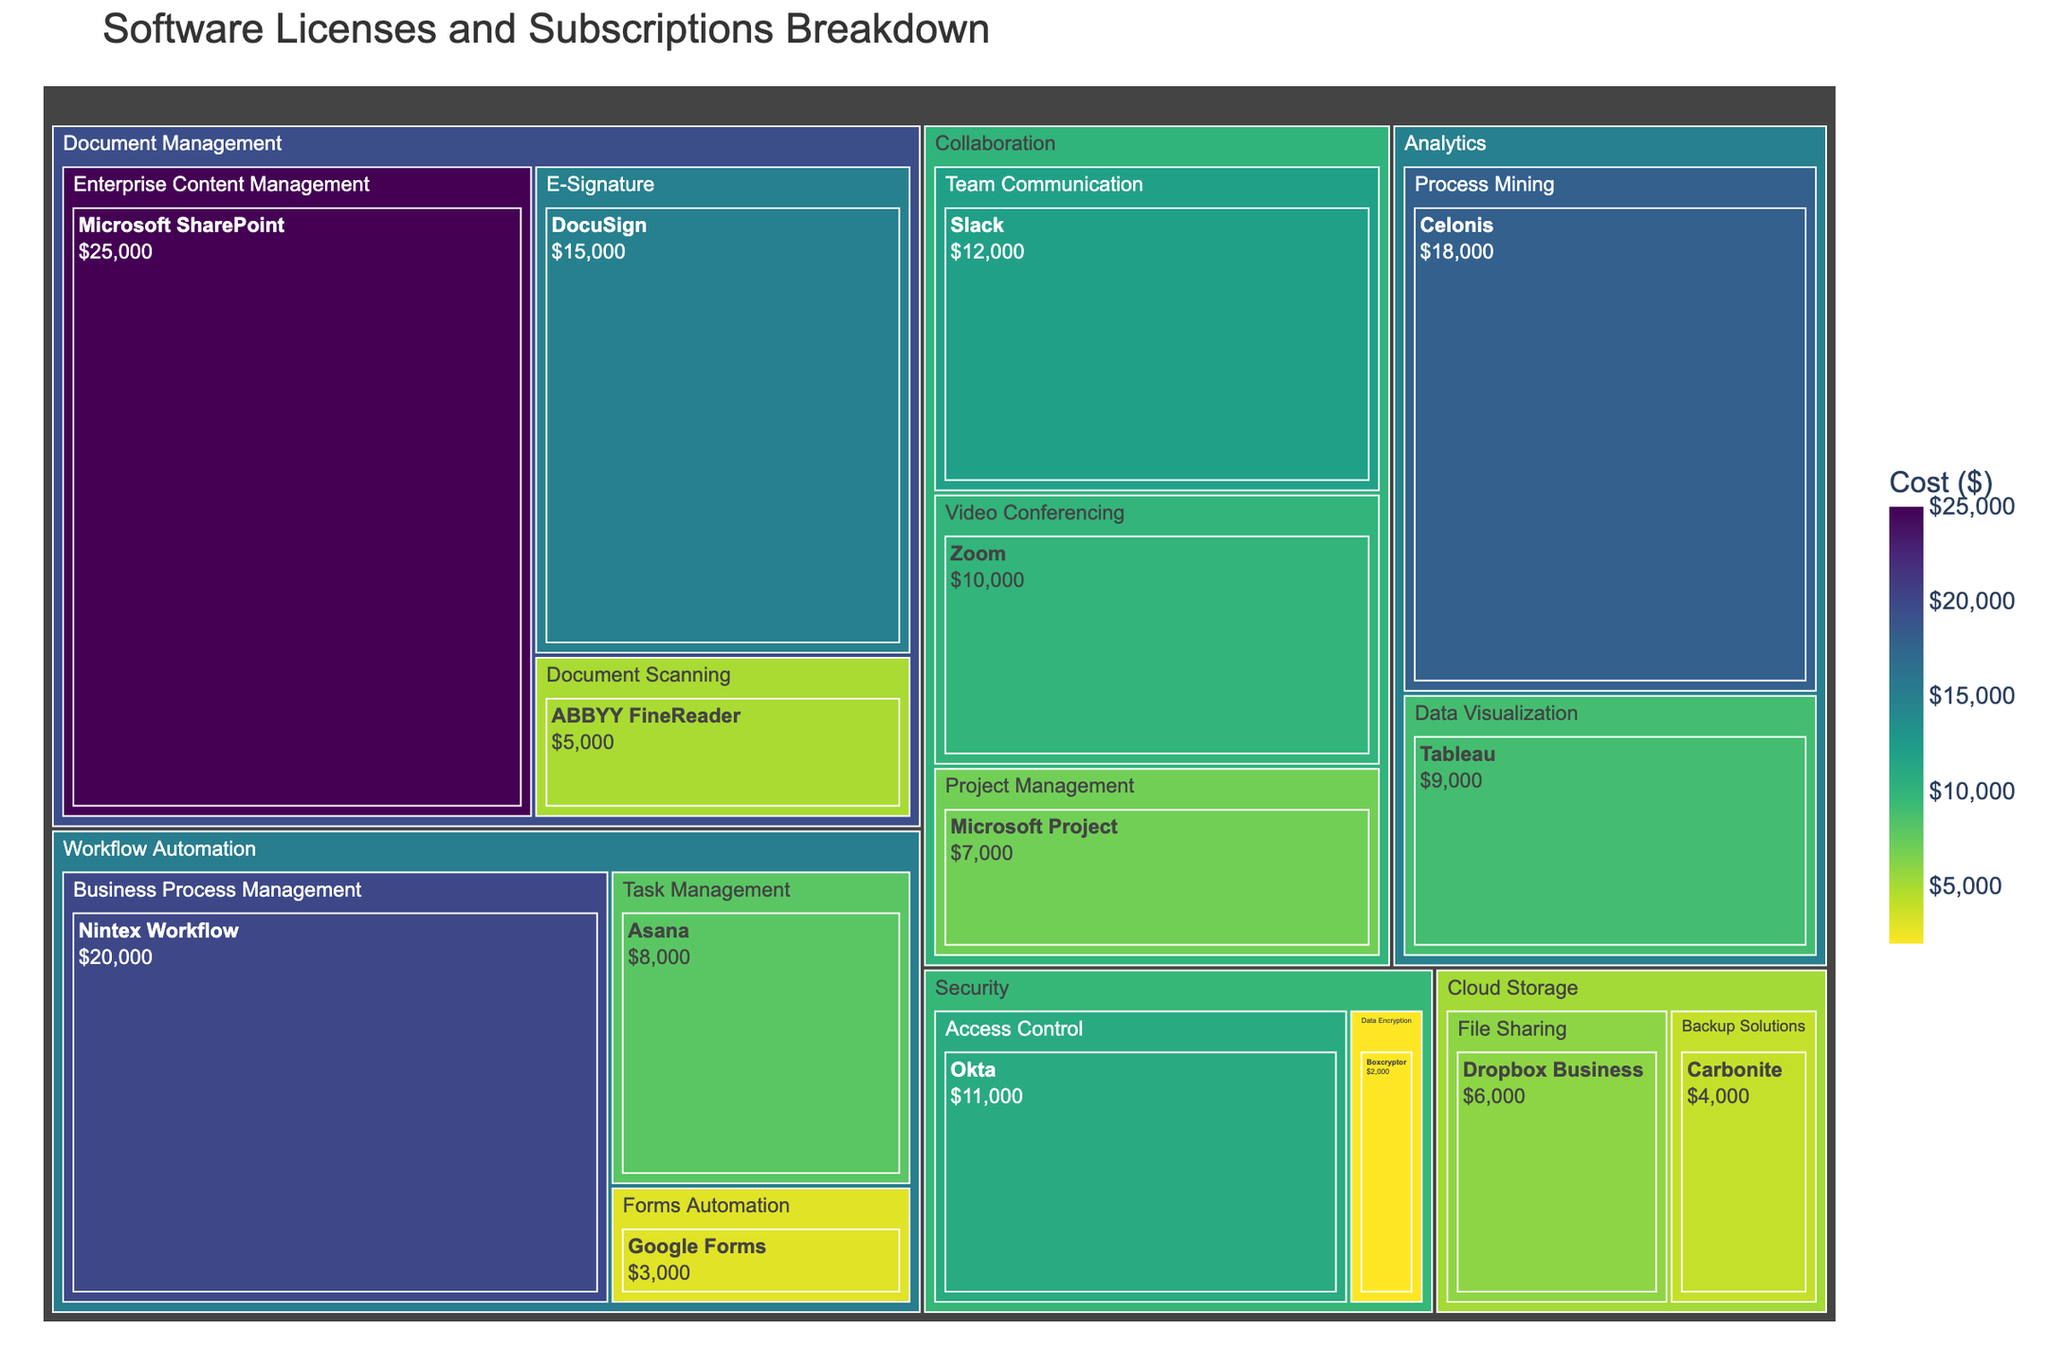What's the total cost of all the software subscriptions and licenses? To find the total cost of all the software subscriptions and licenses, we need to sum the individual costs of each software listed in the treemap. The individual costs are: 25000, 5000, 15000, 20000, 8000, 3000, 12000, 10000, 7000, 6000, 4000, 18000, 9000, 11000, 2000, resulting in 152000.
Answer: 152000 Which category has the highest total cost? To determine the category with the highest total cost, we need to sum the costs of the software within each category and compare. Here are the totals: 
- Document Management: 45000 (25000 + 5000 + 15000)
- Workflow Automation: 31000 (20000 + 8000 + 3000)
- Collaboration: 29000 (12000 + 10000 + 7000)
- Cloud Storage: 10000 (6000 + 4000)
- Analytics: 27000 (18000 + 9000)
- Security: 13000 (11000 + 2000)
Comparing these values, Document Management has the highest total cost of 45000.
Answer: Document Management What is the most expensive software in the Workflow Automation category? The treemap shows the costs of each software in the Workflow Automation category. They are:
- Nintex Workflow: 20000
- Asana: 8000
- Google Forms: 3000
The most expensive software in this category is Nintex Workflow, costing 20000.
Answer: Nintex Workflow How much more expensive is Microsoft SharePoint compared to Dropbox Business? First, find the costs of Microsoft SharePoint and Dropbox Business from the treemap. Microsoft SharePoint costs 25000, and Dropbox Business costs 6000. The difference in cost is 25000 - 6000, which equals 19000.
Answer: 19000 Which category has the least number of software tools listed? To determine this, count the software tools listed under each category in the treemap:
- Document Management: 3
- Workflow Automation: 3
- Collaboration: 3
- Cloud Storage: 2
- Analytics: 2
- Security: 2
Cloud Storage, Analytics, and Security each have the least number, with 2 software tools each.
Answer: Cloud Storage, Analytics, Security What's the total cost of the Collaboration category? To find the total cost of the Collaboration category, sum the costs of the software listed under it in the treemap. The costs are: Slack 12000, Zoom 10000, and Microsoft Project 7000. The total cost is 12000 + 10000 + 7000 = 29000.
Answer: 29000 